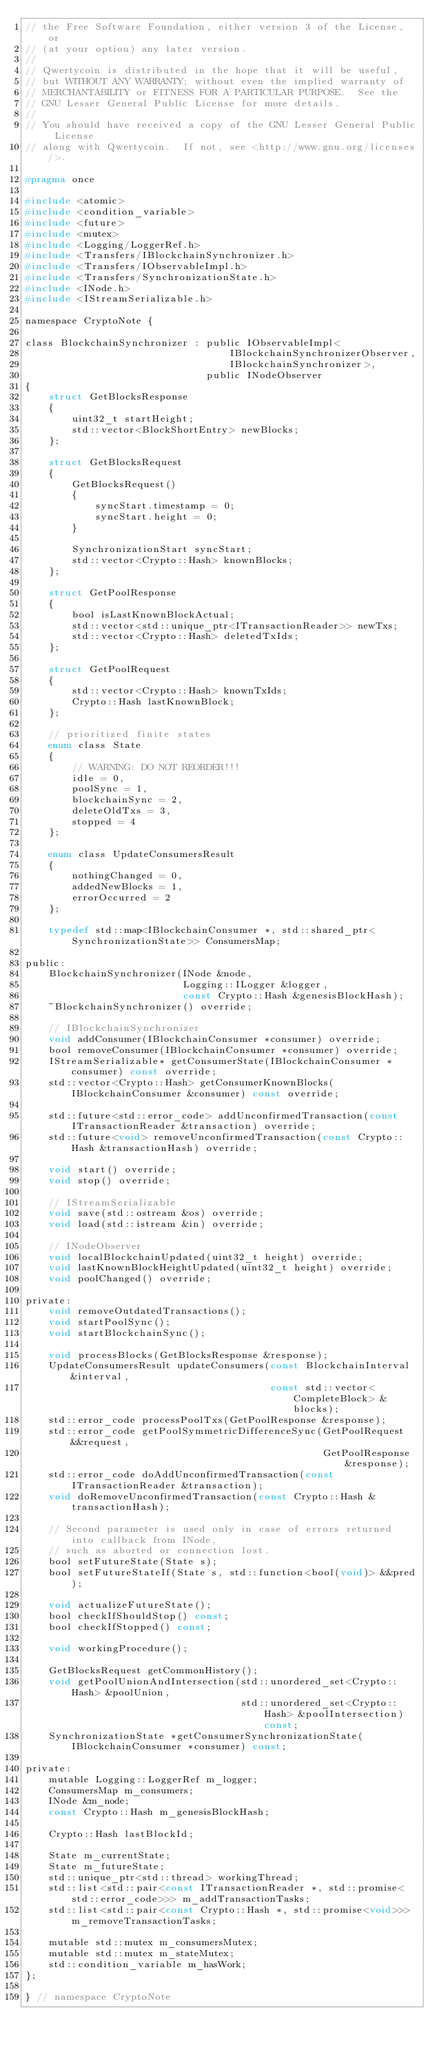<code> <loc_0><loc_0><loc_500><loc_500><_C_>// the Free Software Foundation, either version 3 of the License, or
// (at your option) any later version.
//
// Qwertycoin is distributed in the hope that it will be useful,
// but WITHOUT ANY WARRANTY; without even the implied warranty of
// MERCHANTABILITY or FITNESS FOR A PARTICULAR PURPOSE.  See the
// GNU Lesser General Public License for more details.
//
// You should have received a copy of the GNU Lesser General Public License
// along with Qwertycoin.  If not, see <http://www.gnu.org/licenses/>.

#pragma once

#include <atomic>
#include <condition_variable>
#include <future>
#include <mutex>
#include <Logging/LoggerRef.h>
#include <Transfers/IBlockchainSynchronizer.h>
#include <Transfers/IObservableImpl.h>
#include <Transfers/SynchronizationState.h>
#include <INode.h>
#include <IStreamSerializable.h>

namespace CryptoNote {

class BlockchainSynchronizer : public IObservableImpl<
                                   IBlockchainSynchronizerObserver,
                                   IBlockchainSynchronizer>,
                               public INodeObserver
{
    struct GetBlocksResponse
    {
        uint32_t startHeight;
        std::vector<BlockShortEntry> newBlocks;
    };

    struct GetBlocksRequest
    {
        GetBlocksRequest()
        {
            syncStart.timestamp = 0;
            syncStart.height = 0;
        }

        SynchronizationStart syncStart;
        std::vector<Crypto::Hash> knownBlocks;
    };

    struct GetPoolResponse
    {
        bool isLastKnownBlockActual;
        std::vector<std::unique_ptr<ITransactionReader>> newTxs;
        std::vector<Crypto::Hash> deletedTxIds;
    };

    struct GetPoolRequest
    {
        std::vector<Crypto::Hash> knownTxIds;
        Crypto::Hash lastKnownBlock;
    };

    // prioritized finite states
    enum class State
    {
        // WARNING: DO NOT REORDER!!!
        idle = 0,
        poolSync = 1,
        blockchainSync = 2,
        deleteOldTxs = 3,
        stopped = 4
    };

    enum class UpdateConsumersResult
    {
        nothingChanged = 0,
        addedNewBlocks = 1,
        errorOccurred = 2
    };

    typedef std::map<IBlockchainConsumer *, std::shared_ptr<SynchronizationState>> ConsumersMap;

public:
    BlockchainSynchronizer(INode &node,
                           Logging::ILogger &logger,
                           const Crypto::Hash &genesisBlockHash);
    ~BlockchainSynchronizer() override;

    // IBlockchainSynchronizer
    void addConsumer(IBlockchainConsumer *consumer) override;
    bool removeConsumer(IBlockchainConsumer *consumer) override;
    IStreamSerializable* getConsumerState(IBlockchainConsumer *consumer) const override;
    std::vector<Crypto::Hash> getConsumerKnownBlocks(IBlockchainConsumer &consumer) const override;

    std::future<std::error_code> addUnconfirmedTransaction(const ITransactionReader &transaction) override;
    std::future<void> removeUnconfirmedTransaction(const Crypto::Hash &transactionHash) override;

    void start() override;
    void stop() override;

    // IStreamSerializable
    void save(std::ostream &os) override;
    void load(std::istream &in) override;

    // INodeObserver
    void localBlockchainUpdated(uint32_t height) override;
    void lastKnownBlockHeightUpdated(uint32_t height) override;
    void poolChanged() override;

private:
    void removeOutdatedTransactions();
    void startPoolSync();
    void startBlockchainSync();

    void processBlocks(GetBlocksResponse &response);
    UpdateConsumersResult updateConsumers(const BlockchainInterval &interval,
                                          const std::vector<CompleteBlock> &blocks);
    std::error_code processPoolTxs(GetPoolResponse &response);
    std::error_code getPoolSymmetricDifferenceSync(GetPoolRequest &&request,
                                                   GetPoolResponse &response);
    std::error_code doAddUnconfirmedTransaction(const ITransactionReader &transaction);
    void doRemoveUnconfirmedTransaction(const Crypto::Hash &transactionHash);

    // Second parameter is used only in case of errors returned into callback from INode,
    // such as aborted or connection lost.
    bool setFutureState(State s);
    bool setFutureStateIf(State s, std::function<bool(void)> &&pred);

    void actualizeFutureState();
    bool checkIfShouldStop() const;
    bool checkIfStopped() const;

    void workingProcedure();

    GetBlocksRequest getCommonHistory();
    void getPoolUnionAndIntersection(std::unordered_set<Crypto::Hash> &poolUnion,
                                     std::unordered_set<Crypto::Hash> &poolIntersection) const;
    SynchronizationState *getConsumerSynchronizationState(IBlockchainConsumer *consumer) const;

private:
    mutable Logging::LoggerRef m_logger;
    ConsumersMap m_consumers;
    INode &m_node;
    const Crypto::Hash m_genesisBlockHash;

    Crypto::Hash lastBlockId;

    State m_currentState;
    State m_futureState;
    std::unique_ptr<std::thread> workingThread;
    std::list<std::pair<const ITransactionReader *, std::promise<std::error_code>>> m_addTransactionTasks;
    std::list<std::pair<const Crypto::Hash *, std::promise<void>>> m_removeTransactionTasks;

    mutable std::mutex m_consumersMutex;
    mutable std::mutex m_stateMutex;
    std::condition_variable m_hasWork;
};

} // namespace CryptoNote
</code> 